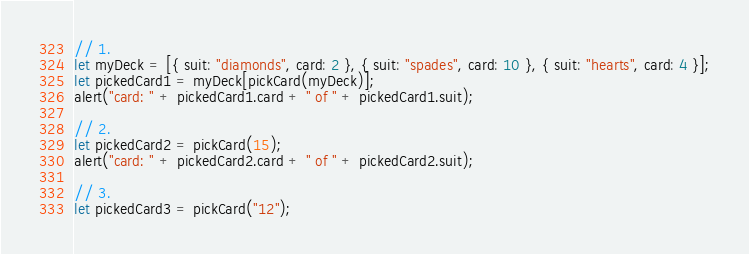Convert code to text. <code><loc_0><loc_0><loc_500><loc_500><_TypeScript_>
// 1.
let myDeck = [{ suit: "diamonds", card: 2 }, { suit: "spades", card: 10 }, { suit: "hearts", card: 4 }];
let pickedCard1 = myDeck[pickCard(myDeck)];
alert("card: " + pickedCard1.card + " of " + pickedCard1.suit);

// 2.
let pickedCard2 = pickCard(15);
alert("card: " + pickedCard2.card + " of " + pickedCard2.suit);

// 3.
let pickedCard3 = pickCard("12");

</code> 